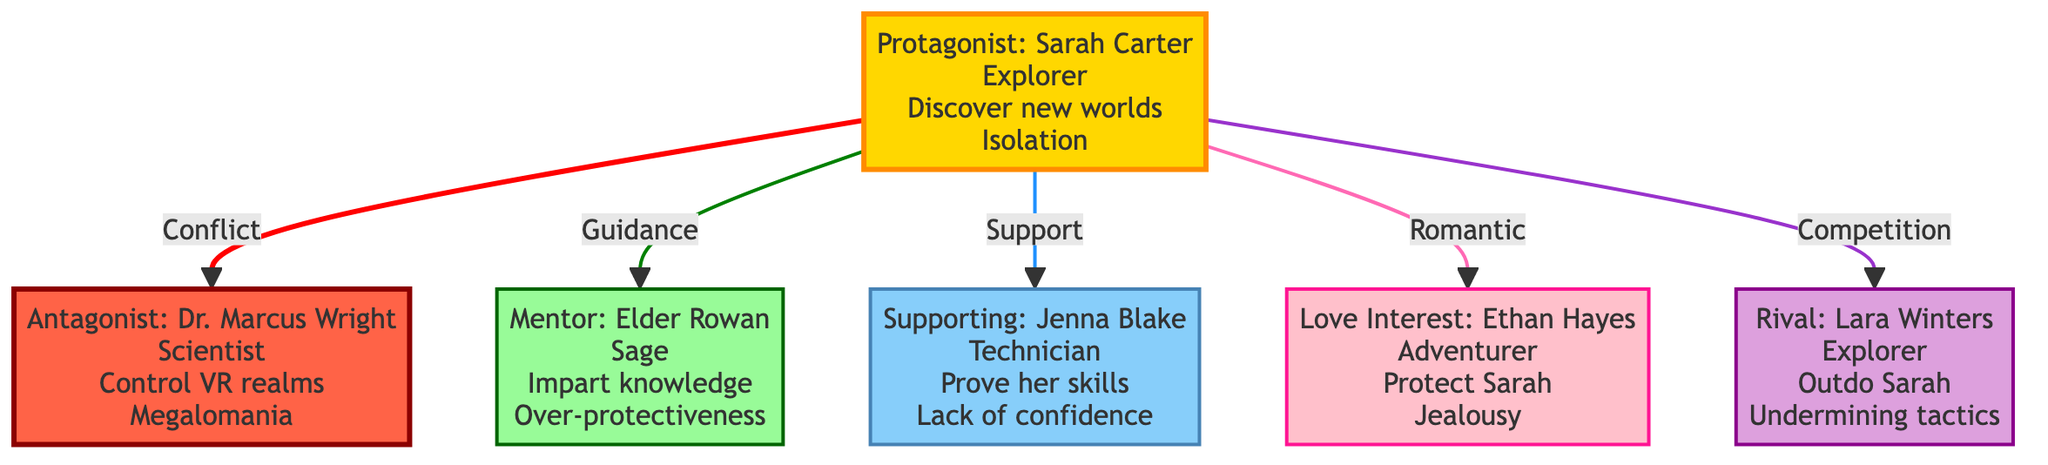What is the protagonist's name? The protagonist's block specifically lists the name "Sarah Carter" under its attributes, which represents the main character in the story world.
Answer: Sarah Carter How many characters are depicted in the diagram? The diagram shows a total of six characters, indicated by six separate blocks labeled accordingly: Protagonist, Antagonist, Mentor, Supporting Character, Love Interest, and Rival.
Answer: Six What type of relationship exists between Sarah Carter and Dr. Marcus Wright? The diagram illustrates a "Conflict" relationship between the Protagonist (Sarah Carter) and the Antagonist (Dr. Marcus Wright), highlighting the primary antagonistic dynamic in the story.
Answer: Conflict Which character provides guidance to the protagonist? The connection labeled "Guidance" between the protagonist (Sarah Carter) and the mentor (Elder Rowan) clearly identifies Elder Rowan as the character that supports the protagonist through advice and wisdom.
Answer: Elder Rowan What is Jenna Blake's role in relation to Sarah Carter? The diagram shows that Jenna Blake has a "Support" relationship with Sarah Carter, depicting her as a supporting character who aids the protagonist in various ways.
Answer: Supporting Character Who is Sarah Carter's love interest? According to the diagram, the relationship labeled "Romantic" links Sarah Carter to Ethan Hayes, indicating that Ethan is the character that adds emotional depth and personal stakes as her love interest.
Answer: Ethan Hayes What is the key conflict of the antagonist Dr. Marcus Wright? The attributes of Dr. Marcus Wright specify "Megalomania" as his key conflict, which is crucial for understanding his motivations as the opposing force in the narrative.
Answer: Megalomania What type of relationship characterizes the dynamic between Sarah Carter and Lara Winters? The diagram denotes a "Competition" relationship between Sarah Carter and Lara Winters, indicating that this dynamic involves rivalry and competition.
Answer: Competition How does Elder Rowan affect Sarah Carter's conflicts? The diagram indicates that Elder Rowan provides "Guidance," suggesting that while he supports Sarah Carter, he also has a key conflict of "Over-protectiveness," which may complicate their relationship.
Answer: Guidance 